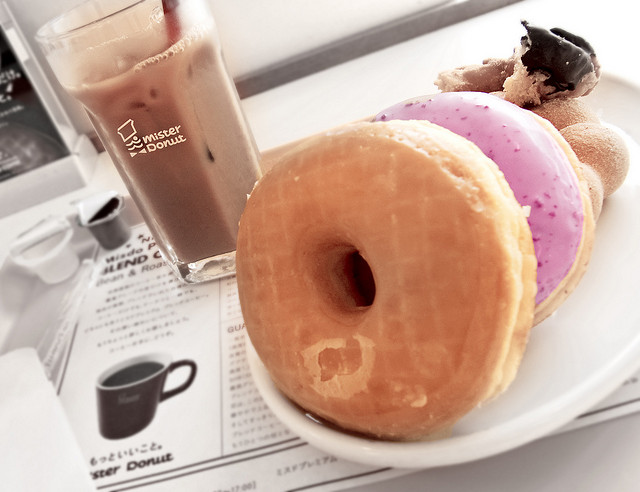How many fins does the surfboard have? The image does not show a surfboard; it depicts a selection of donuts and a glass of iced coffee on a table. As there is no surfboard present in the image, the question about the number of fins is not applicable. 